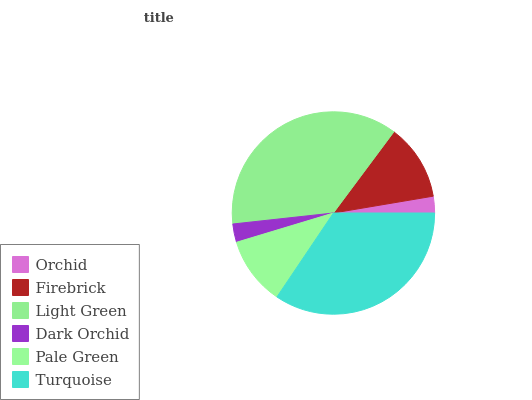Is Orchid the minimum?
Answer yes or no. Yes. Is Light Green the maximum?
Answer yes or no. Yes. Is Firebrick the minimum?
Answer yes or no. No. Is Firebrick the maximum?
Answer yes or no. No. Is Firebrick greater than Orchid?
Answer yes or no. Yes. Is Orchid less than Firebrick?
Answer yes or no. Yes. Is Orchid greater than Firebrick?
Answer yes or no. No. Is Firebrick less than Orchid?
Answer yes or no. No. Is Firebrick the high median?
Answer yes or no. Yes. Is Pale Green the low median?
Answer yes or no. Yes. Is Orchid the high median?
Answer yes or no. No. Is Turquoise the low median?
Answer yes or no. No. 